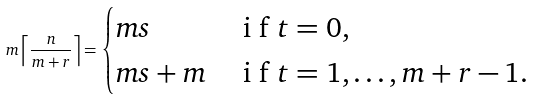<formula> <loc_0><loc_0><loc_500><loc_500>m \left \lceil \frac { n } { m + r } \right \rceil = \begin{cases} m s & $ i f $ t = 0 , \\ m s + m & $ i f $ t = 1 , \dots , m + r - 1 . \end{cases}</formula> 